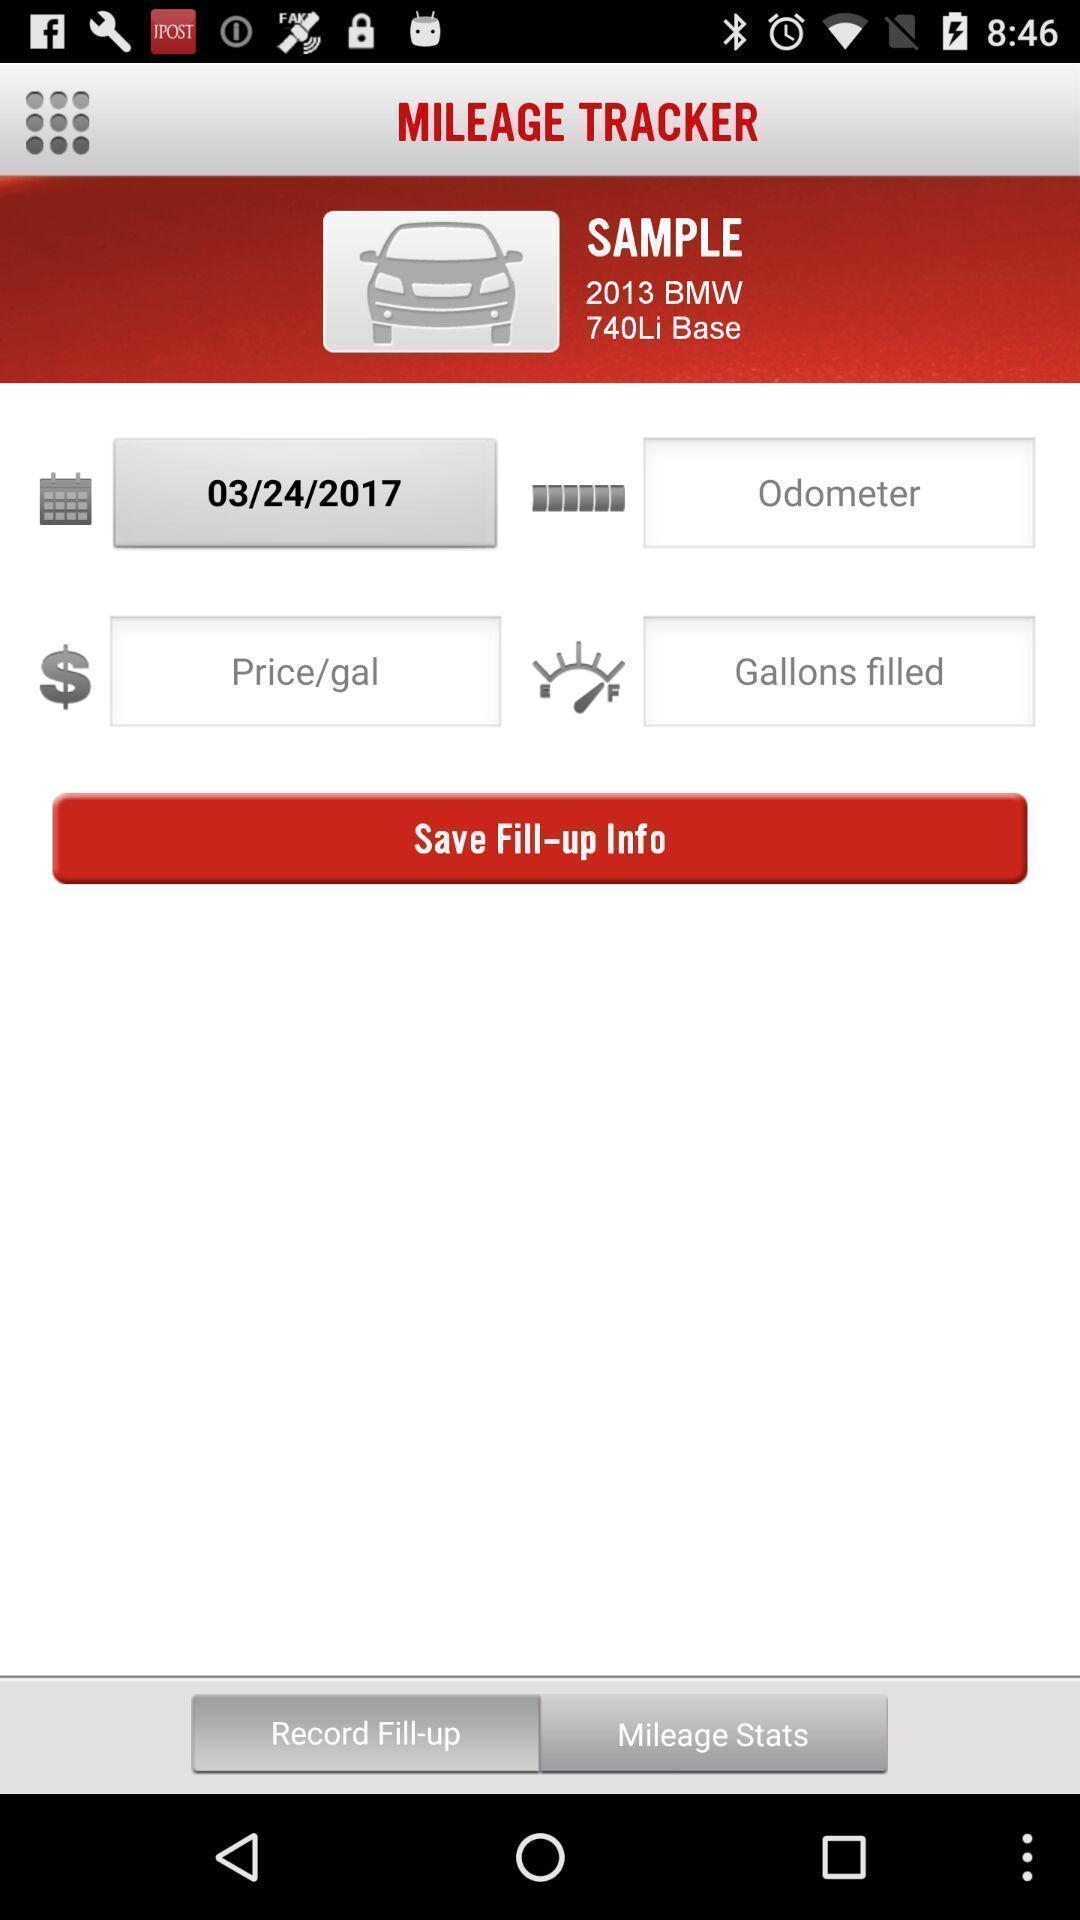Describe the visual elements of this screenshot. Screen shows tracker page of mileage tracking app. 